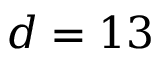<formula> <loc_0><loc_0><loc_500><loc_500>d = 1 3</formula> 